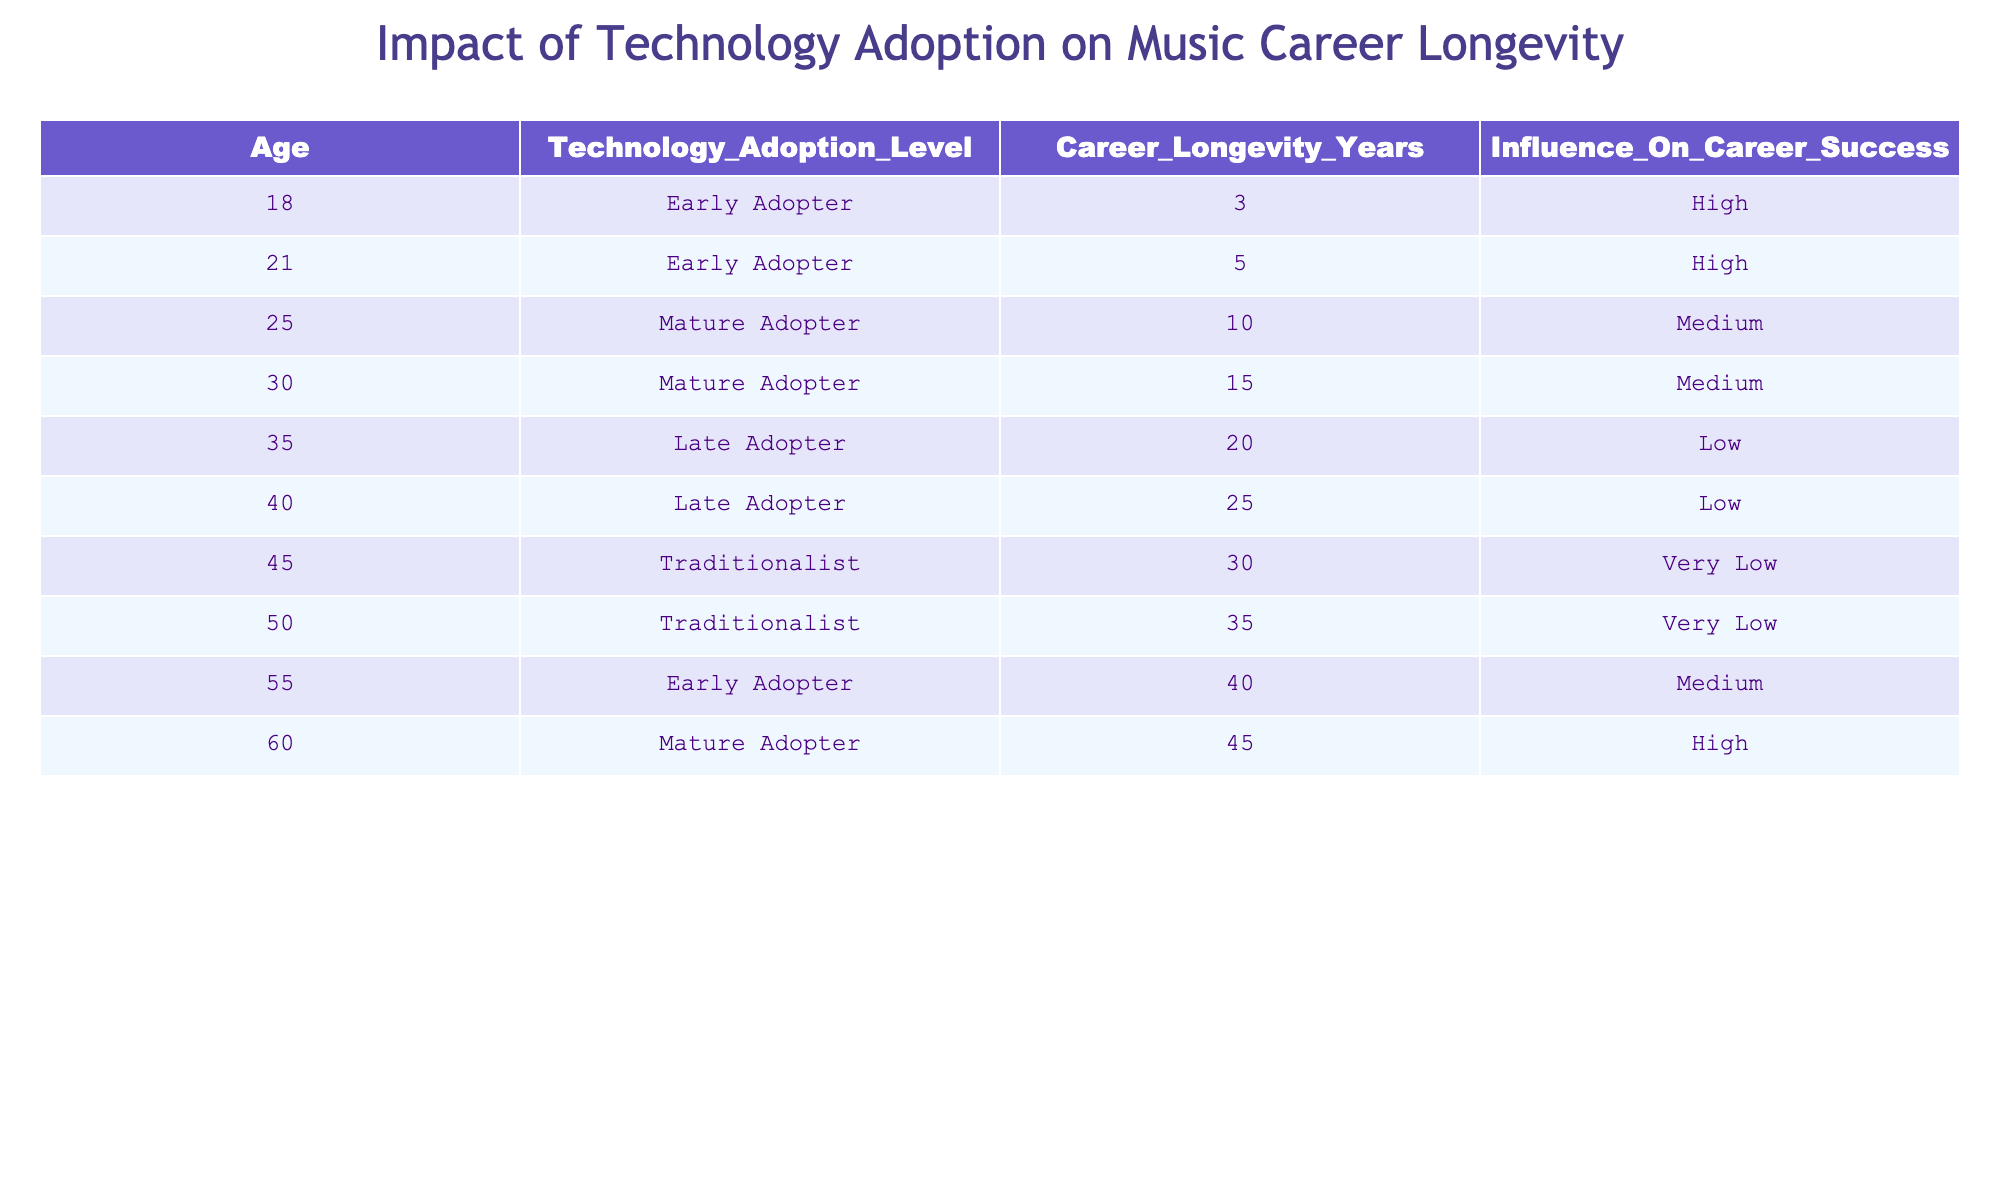What is the Technology Adoption Level at age 30? Looking at the row corresponding to age 30, the Technology Adoption Level listed is 'Mature Adopter'.
Answer: Mature Adopter How many years of career longevity does a Late Adopter have at age 40? Referring to the entry for age 40 under Late Adopter, the Career Longevity Years is noted as 25.
Answer: 25 What is the influence on career success for a Traditionalist at age 50? For the entry designated as age 50 with a Technology Adoption Level of Traditionalist, the Influence On Career Success is labeled as 'Very Low'.
Answer: Very Low What is the average career longevity for Early Adopters? The Career Longevity Years for Early Adopters are 3, 5, and 40. Adding these gives 3 + 5 + 40 = 48. Dividing by 3 (the number of Early Adopters) yields an average of 48 / 3 = 16.
Answer: 16 Is it true that a Mature Adopter has a higher career longevity than a Late Adopter? Examining the Career Longevity Years of Mature Adopters (10, 15, 45) compared to Late Adopters (20, 25), it is clear that Late Adopters have higher values. Therefore, the statement is false.
Answer: No What is the total career longevity for all Traditionalists combined? The Career Longevity Years for Traditionalists at ages 45 and 50 are 30 and 35, respectively. Adding these together gives 30 + 35 = 65.
Answer: 65 How many entries show a 'High' influence on career success? By scanning the table, there are three entries labeled 'High' for Influence On Career Success (ages 18, 21, and 60). So, the count is 3.
Answer: 3 What age has the highest career longevity and what is that value? The entry for age 60 indicates the highest Career Longevity Years of 45 among all data points.
Answer: 60, 45 At what ages are individuals classified as Traditionalists? Looking at the table, Traditionalists are listed at ages 45 and 50. Thus, the ages are 45 and 50.
Answer: 45, 50 